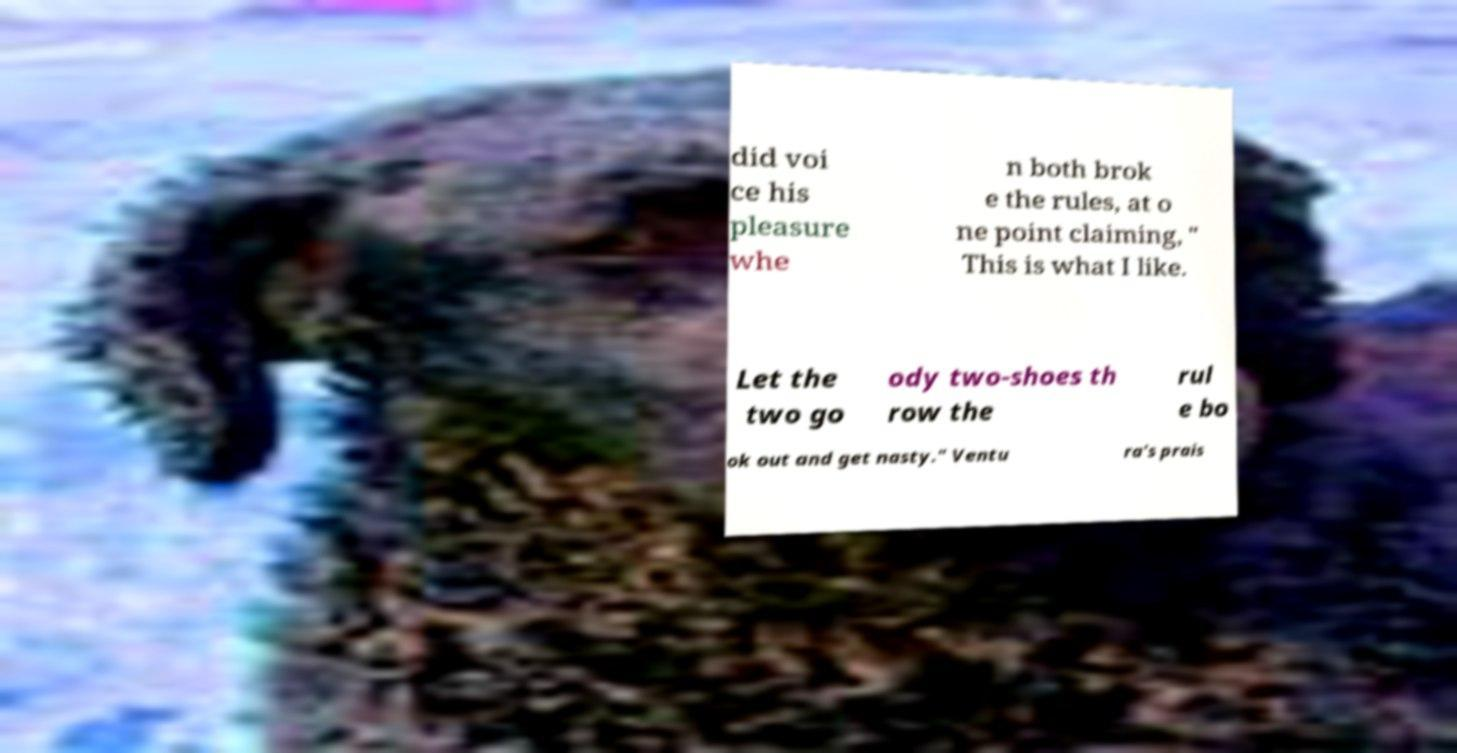Could you extract and type out the text from this image? did voi ce his pleasure whe n both brok e the rules, at o ne point claiming, " This is what I like. Let the two go ody two-shoes th row the rul e bo ok out and get nasty." Ventu ra's prais 